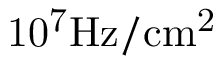<formula> <loc_0><loc_0><loc_500><loc_500>1 0 ^ { 7 } H z / c m ^ { 2 }</formula> 